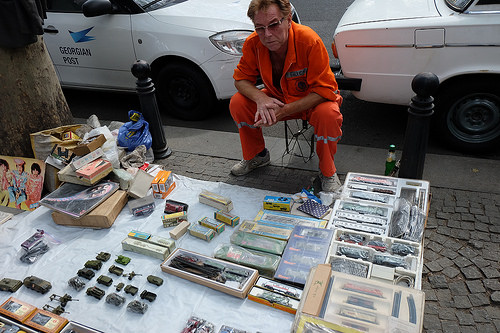<image>
Is the paper under the products? Yes. The paper is positioned underneath the products, with the products above it in the vertical space. Is there a vehicle behind the picture? Yes. From this viewpoint, the vehicle is positioned behind the picture, with the picture partially or fully occluding the vehicle. 